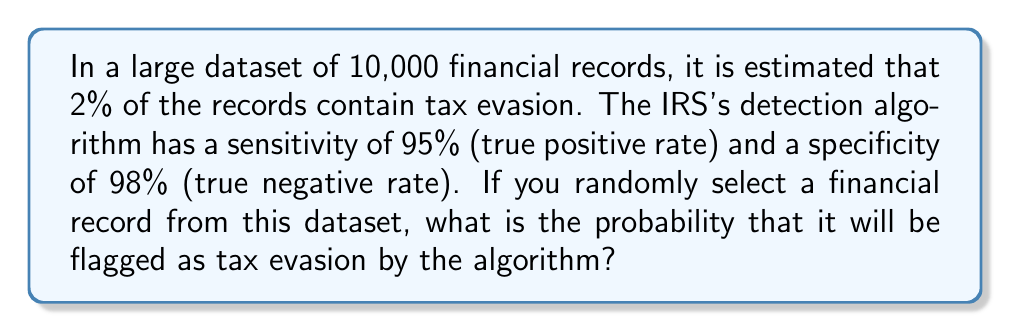Provide a solution to this math problem. Let's approach this step-by-step:

1) First, let's define our events:
   A: The record actually contains tax evasion
   B: The record is flagged as tax evasion by the algorithm

2) We're given:
   P(A) = 0.02 (2% of records contain tax evasion)
   P(B|A) = 0.95 (sensitivity, or true positive rate)
   P(not B|not A) = 0.98 (specificity, or true negative rate)

3) We need to find P(B), which we can calculate using the law of total probability:

   $$P(B) = P(B|A) \cdot P(A) + P(B|not A) \cdot P(not A)$$

4) We know P(B|A), P(A), and P(not A) = 1 - P(A) = 0.98

5) We can find P(B|not A) from the specificity:
   P(not B|not A) = 0.98
   P(B|not A) = 1 - 0.98 = 0.02

6) Now we can plug everything into our equation:

   $$P(B) = 0.95 \cdot 0.02 + 0.02 \cdot 0.98$$

7) Let's calculate:
   $$P(B) = 0.019 + 0.0196 = 0.0386$$

8) Convert to a percentage:
   0.0386 * 100 = 3.86%
Answer: 3.86% 